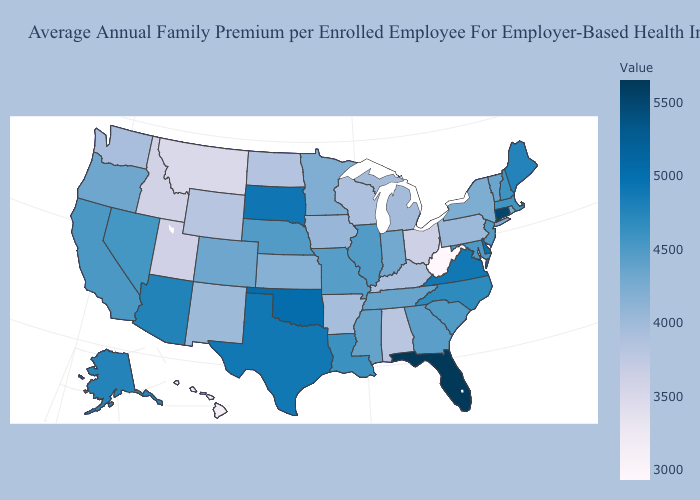Does New Jersey have a higher value than Virginia?
Quick response, please. No. Does Rhode Island have a lower value than Kentucky?
Write a very short answer. No. Which states have the lowest value in the USA?
Short answer required. West Virginia. Does Mississippi have the lowest value in the USA?
Concise answer only. No. Which states hav the highest value in the MidWest?
Concise answer only. South Dakota. 